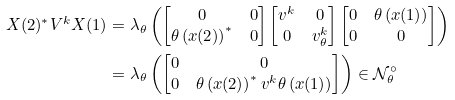Convert formula to latex. <formula><loc_0><loc_0><loc_500><loc_500>X ( 2 ) ^ { * } V ^ { k } X ( 1 ) & = \lambda _ { \theta } \left ( \begin{bmatrix} 0 & 0 \\ \theta \left ( x ( 2 ) \right ) ^ { * } & 0 \end{bmatrix} \begin{bmatrix} v ^ { k } & 0 \\ 0 & v _ { \theta } ^ { k } \end{bmatrix} \begin{bmatrix} 0 & \theta \left ( x ( 1 ) \right ) \\ 0 & 0 \end{bmatrix} \right ) \\ & = \lambda _ { \theta } \left ( \begin{bmatrix} 0 & 0 \\ 0 & \theta \left ( x ( 2 ) \right ) ^ { * } v ^ { k } \theta \left ( x ( 1 ) \right ) \end{bmatrix} \right ) \in { \mathcal { N } } _ { \theta } ^ { \circ }</formula> 